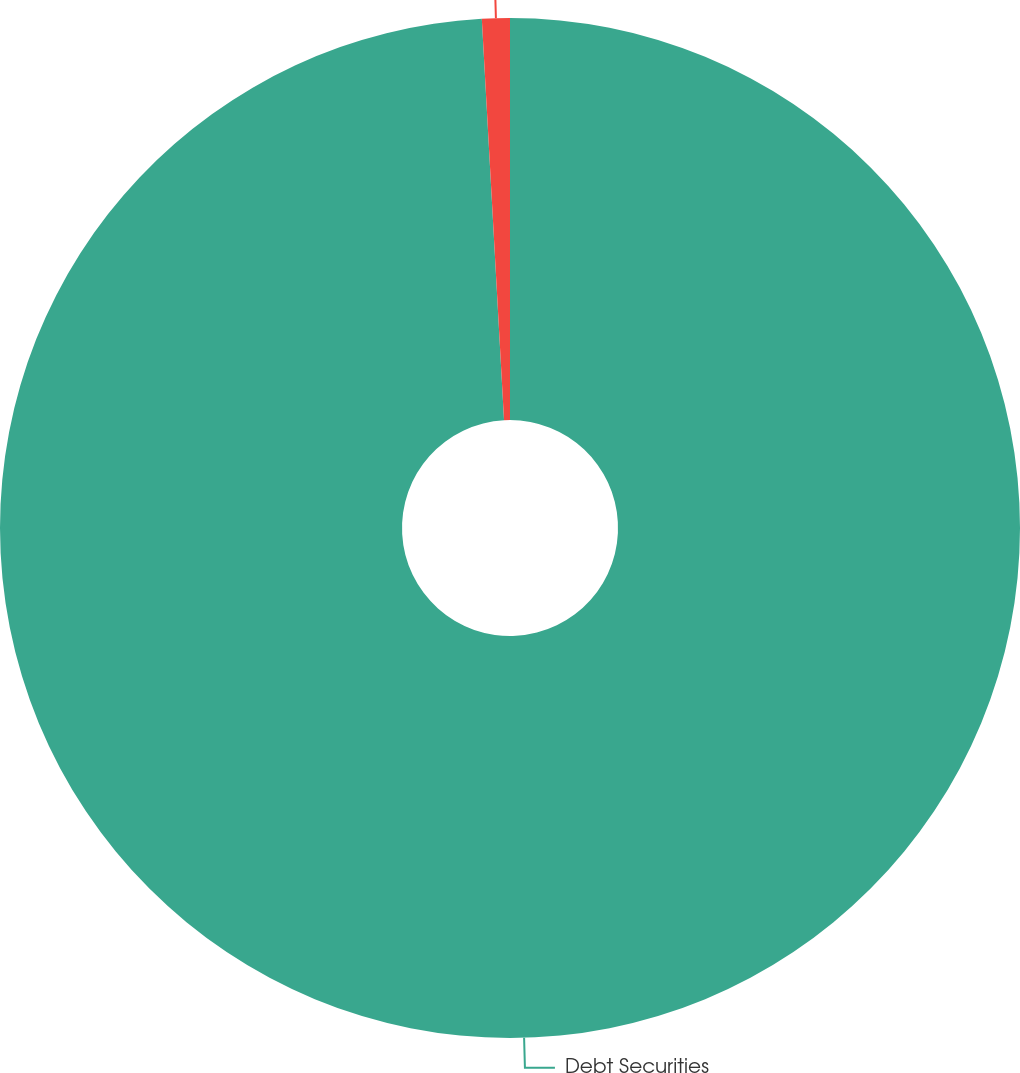Convert chart. <chart><loc_0><loc_0><loc_500><loc_500><pie_chart><fcel>Debt Securities<fcel>Real Estate<nl><fcel>99.12%<fcel>0.88%<nl></chart> 